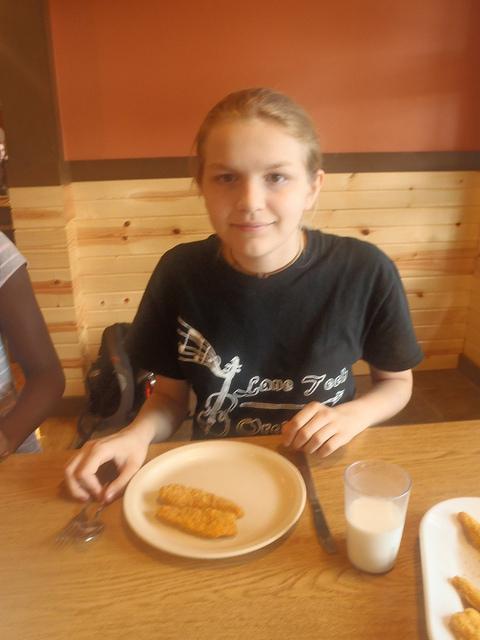How many people are there?
Give a very brief answer. 2. 